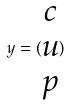Convert formula to latex. <formula><loc_0><loc_0><loc_500><loc_500>y = ( \begin{matrix} c \\ u \\ p \end{matrix} )</formula> 